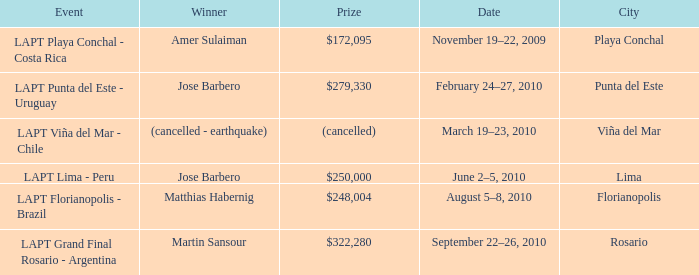Who is the winner in the city of lima? Jose Barbero. 